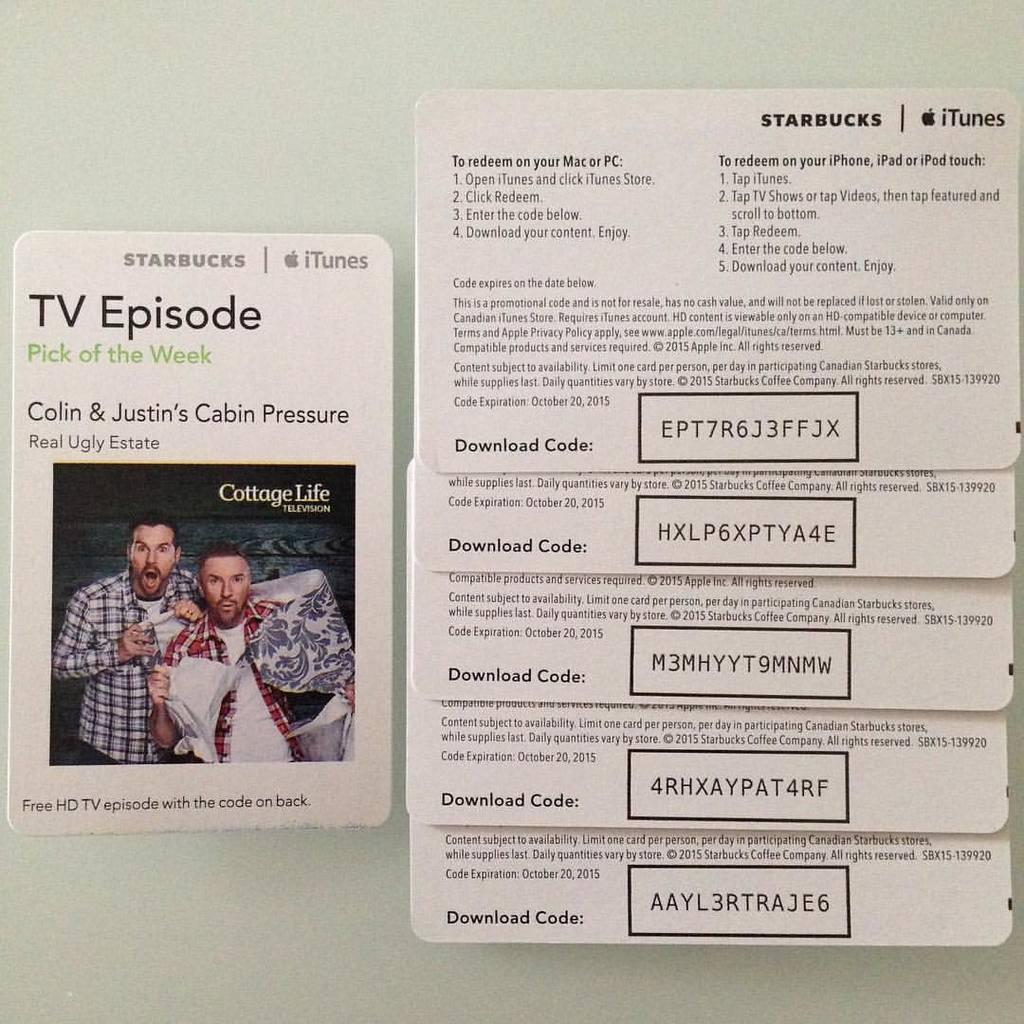Can you describe this image briefly? In this image, we can see few cards. There is some text, boxes, numerical number, image on cards. These cards are placed on a white surface. 